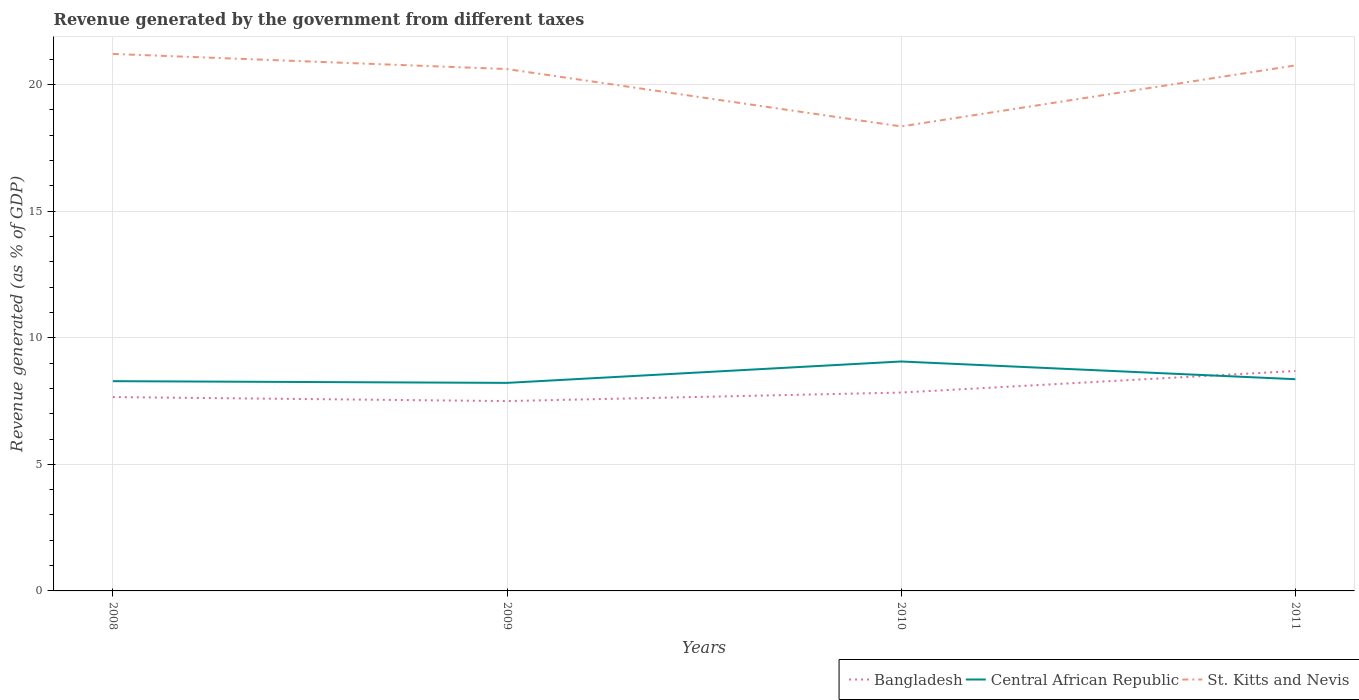Across all years, what is the maximum revenue generated by the government in St. Kitts and Nevis?
Offer a very short reply. 18.35. What is the total revenue generated by the government in Bangladesh in the graph?
Keep it short and to the point. -0.18. What is the difference between the highest and the second highest revenue generated by the government in Bangladesh?
Ensure brevity in your answer.  1.19. What is the difference between the highest and the lowest revenue generated by the government in St. Kitts and Nevis?
Offer a terse response. 3. Is the revenue generated by the government in St. Kitts and Nevis strictly greater than the revenue generated by the government in Central African Republic over the years?
Keep it short and to the point. No. How many years are there in the graph?
Your answer should be compact. 4. What is the difference between two consecutive major ticks on the Y-axis?
Your response must be concise. 5. Are the values on the major ticks of Y-axis written in scientific E-notation?
Provide a short and direct response. No. Does the graph contain any zero values?
Keep it short and to the point. No. Does the graph contain grids?
Give a very brief answer. Yes. Where does the legend appear in the graph?
Provide a short and direct response. Bottom right. What is the title of the graph?
Offer a terse response. Revenue generated by the government from different taxes. Does "Sao Tome and Principe" appear as one of the legend labels in the graph?
Give a very brief answer. No. What is the label or title of the X-axis?
Your response must be concise. Years. What is the label or title of the Y-axis?
Give a very brief answer. Revenue generated (as % of GDP). What is the Revenue generated (as % of GDP) of Bangladesh in 2008?
Your response must be concise. 7.66. What is the Revenue generated (as % of GDP) in Central African Republic in 2008?
Offer a terse response. 8.28. What is the Revenue generated (as % of GDP) in St. Kitts and Nevis in 2008?
Keep it short and to the point. 21.21. What is the Revenue generated (as % of GDP) in Bangladesh in 2009?
Your answer should be very brief. 7.5. What is the Revenue generated (as % of GDP) in Central African Republic in 2009?
Provide a succinct answer. 8.22. What is the Revenue generated (as % of GDP) of St. Kitts and Nevis in 2009?
Offer a very short reply. 20.61. What is the Revenue generated (as % of GDP) in Bangladesh in 2010?
Make the answer very short. 7.83. What is the Revenue generated (as % of GDP) in Central African Republic in 2010?
Your response must be concise. 9.06. What is the Revenue generated (as % of GDP) of St. Kitts and Nevis in 2010?
Offer a very short reply. 18.35. What is the Revenue generated (as % of GDP) of Bangladesh in 2011?
Your answer should be compact. 8.69. What is the Revenue generated (as % of GDP) of Central African Republic in 2011?
Give a very brief answer. 8.36. What is the Revenue generated (as % of GDP) of St. Kitts and Nevis in 2011?
Offer a terse response. 20.76. Across all years, what is the maximum Revenue generated (as % of GDP) of Bangladesh?
Offer a very short reply. 8.69. Across all years, what is the maximum Revenue generated (as % of GDP) in Central African Republic?
Make the answer very short. 9.06. Across all years, what is the maximum Revenue generated (as % of GDP) of St. Kitts and Nevis?
Your answer should be very brief. 21.21. Across all years, what is the minimum Revenue generated (as % of GDP) of Bangladesh?
Provide a short and direct response. 7.5. Across all years, what is the minimum Revenue generated (as % of GDP) in Central African Republic?
Make the answer very short. 8.22. Across all years, what is the minimum Revenue generated (as % of GDP) of St. Kitts and Nevis?
Make the answer very short. 18.35. What is the total Revenue generated (as % of GDP) in Bangladesh in the graph?
Offer a very short reply. 31.67. What is the total Revenue generated (as % of GDP) of Central African Republic in the graph?
Keep it short and to the point. 33.93. What is the total Revenue generated (as % of GDP) in St. Kitts and Nevis in the graph?
Keep it short and to the point. 80.92. What is the difference between the Revenue generated (as % of GDP) of Bangladesh in 2008 and that in 2009?
Your answer should be very brief. 0.16. What is the difference between the Revenue generated (as % of GDP) in Central African Republic in 2008 and that in 2009?
Offer a terse response. 0.07. What is the difference between the Revenue generated (as % of GDP) of St. Kitts and Nevis in 2008 and that in 2009?
Ensure brevity in your answer.  0.6. What is the difference between the Revenue generated (as % of GDP) in Bangladesh in 2008 and that in 2010?
Your answer should be very brief. -0.18. What is the difference between the Revenue generated (as % of GDP) of Central African Republic in 2008 and that in 2010?
Offer a terse response. -0.78. What is the difference between the Revenue generated (as % of GDP) of St. Kitts and Nevis in 2008 and that in 2010?
Give a very brief answer. 2.86. What is the difference between the Revenue generated (as % of GDP) of Bangladesh in 2008 and that in 2011?
Make the answer very short. -1.03. What is the difference between the Revenue generated (as % of GDP) of Central African Republic in 2008 and that in 2011?
Offer a very short reply. -0.08. What is the difference between the Revenue generated (as % of GDP) in St. Kitts and Nevis in 2008 and that in 2011?
Your answer should be compact. 0.45. What is the difference between the Revenue generated (as % of GDP) of Bangladesh in 2009 and that in 2010?
Your answer should be very brief. -0.34. What is the difference between the Revenue generated (as % of GDP) in Central African Republic in 2009 and that in 2010?
Your answer should be compact. -0.84. What is the difference between the Revenue generated (as % of GDP) of St. Kitts and Nevis in 2009 and that in 2010?
Keep it short and to the point. 2.27. What is the difference between the Revenue generated (as % of GDP) of Bangladesh in 2009 and that in 2011?
Provide a short and direct response. -1.19. What is the difference between the Revenue generated (as % of GDP) in Central African Republic in 2009 and that in 2011?
Provide a succinct answer. -0.14. What is the difference between the Revenue generated (as % of GDP) in St. Kitts and Nevis in 2009 and that in 2011?
Offer a terse response. -0.14. What is the difference between the Revenue generated (as % of GDP) of Bangladesh in 2010 and that in 2011?
Your answer should be compact. -0.85. What is the difference between the Revenue generated (as % of GDP) of Central African Republic in 2010 and that in 2011?
Offer a terse response. 0.7. What is the difference between the Revenue generated (as % of GDP) in St. Kitts and Nevis in 2010 and that in 2011?
Your response must be concise. -2.41. What is the difference between the Revenue generated (as % of GDP) of Bangladesh in 2008 and the Revenue generated (as % of GDP) of Central African Republic in 2009?
Keep it short and to the point. -0.56. What is the difference between the Revenue generated (as % of GDP) in Bangladesh in 2008 and the Revenue generated (as % of GDP) in St. Kitts and Nevis in 2009?
Keep it short and to the point. -12.96. What is the difference between the Revenue generated (as % of GDP) of Central African Republic in 2008 and the Revenue generated (as % of GDP) of St. Kitts and Nevis in 2009?
Make the answer very short. -12.33. What is the difference between the Revenue generated (as % of GDP) in Bangladesh in 2008 and the Revenue generated (as % of GDP) in Central African Republic in 2010?
Your answer should be very brief. -1.41. What is the difference between the Revenue generated (as % of GDP) in Bangladesh in 2008 and the Revenue generated (as % of GDP) in St. Kitts and Nevis in 2010?
Provide a short and direct response. -10.69. What is the difference between the Revenue generated (as % of GDP) of Central African Republic in 2008 and the Revenue generated (as % of GDP) of St. Kitts and Nevis in 2010?
Make the answer very short. -10.06. What is the difference between the Revenue generated (as % of GDP) in Bangladesh in 2008 and the Revenue generated (as % of GDP) in Central African Republic in 2011?
Your answer should be very brief. -0.71. What is the difference between the Revenue generated (as % of GDP) in Bangladesh in 2008 and the Revenue generated (as % of GDP) in St. Kitts and Nevis in 2011?
Keep it short and to the point. -13.1. What is the difference between the Revenue generated (as % of GDP) of Central African Republic in 2008 and the Revenue generated (as % of GDP) of St. Kitts and Nevis in 2011?
Your answer should be compact. -12.47. What is the difference between the Revenue generated (as % of GDP) of Bangladesh in 2009 and the Revenue generated (as % of GDP) of Central African Republic in 2010?
Ensure brevity in your answer.  -1.56. What is the difference between the Revenue generated (as % of GDP) in Bangladesh in 2009 and the Revenue generated (as % of GDP) in St. Kitts and Nevis in 2010?
Provide a short and direct response. -10.85. What is the difference between the Revenue generated (as % of GDP) in Central African Republic in 2009 and the Revenue generated (as % of GDP) in St. Kitts and Nevis in 2010?
Keep it short and to the point. -10.13. What is the difference between the Revenue generated (as % of GDP) of Bangladesh in 2009 and the Revenue generated (as % of GDP) of Central African Republic in 2011?
Offer a very short reply. -0.86. What is the difference between the Revenue generated (as % of GDP) in Bangladesh in 2009 and the Revenue generated (as % of GDP) in St. Kitts and Nevis in 2011?
Keep it short and to the point. -13.26. What is the difference between the Revenue generated (as % of GDP) of Central African Republic in 2009 and the Revenue generated (as % of GDP) of St. Kitts and Nevis in 2011?
Your answer should be compact. -12.54. What is the difference between the Revenue generated (as % of GDP) of Bangladesh in 2010 and the Revenue generated (as % of GDP) of Central African Republic in 2011?
Offer a terse response. -0.53. What is the difference between the Revenue generated (as % of GDP) in Bangladesh in 2010 and the Revenue generated (as % of GDP) in St. Kitts and Nevis in 2011?
Offer a terse response. -12.92. What is the difference between the Revenue generated (as % of GDP) of Central African Republic in 2010 and the Revenue generated (as % of GDP) of St. Kitts and Nevis in 2011?
Keep it short and to the point. -11.69. What is the average Revenue generated (as % of GDP) of Bangladesh per year?
Your answer should be very brief. 7.92. What is the average Revenue generated (as % of GDP) of Central African Republic per year?
Keep it short and to the point. 8.48. What is the average Revenue generated (as % of GDP) in St. Kitts and Nevis per year?
Your answer should be very brief. 20.23. In the year 2008, what is the difference between the Revenue generated (as % of GDP) of Bangladesh and Revenue generated (as % of GDP) of Central African Republic?
Your response must be concise. -0.63. In the year 2008, what is the difference between the Revenue generated (as % of GDP) in Bangladesh and Revenue generated (as % of GDP) in St. Kitts and Nevis?
Give a very brief answer. -13.55. In the year 2008, what is the difference between the Revenue generated (as % of GDP) in Central African Republic and Revenue generated (as % of GDP) in St. Kitts and Nevis?
Provide a succinct answer. -12.92. In the year 2009, what is the difference between the Revenue generated (as % of GDP) in Bangladesh and Revenue generated (as % of GDP) in Central African Republic?
Offer a very short reply. -0.72. In the year 2009, what is the difference between the Revenue generated (as % of GDP) in Bangladesh and Revenue generated (as % of GDP) in St. Kitts and Nevis?
Offer a very short reply. -13.11. In the year 2009, what is the difference between the Revenue generated (as % of GDP) in Central African Republic and Revenue generated (as % of GDP) in St. Kitts and Nevis?
Provide a short and direct response. -12.39. In the year 2010, what is the difference between the Revenue generated (as % of GDP) in Bangladesh and Revenue generated (as % of GDP) in Central African Republic?
Make the answer very short. -1.23. In the year 2010, what is the difference between the Revenue generated (as % of GDP) of Bangladesh and Revenue generated (as % of GDP) of St. Kitts and Nevis?
Provide a short and direct response. -10.51. In the year 2010, what is the difference between the Revenue generated (as % of GDP) of Central African Republic and Revenue generated (as % of GDP) of St. Kitts and Nevis?
Ensure brevity in your answer.  -9.28. In the year 2011, what is the difference between the Revenue generated (as % of GDP) in Bangladesh and Revenue generated (as % of GDP) in Central African Republic?
Ensure brevity in your answer.  0.32. In the year 2011, what is the difference between the Revenue generated (as % of GDP) in Bangladesh and Revenue generated (as % of GDP) in St. Kitts and Nevis?
Your answer should be very brief. -12.07. In the year 2011, what is the difference between the Revenue generated (as % of GDP) in Central African Republic and Revenue generated (as % of GDP) in St. Kitts and Nevis?
Offer a terse response. -12.39. What is the ratio of the Revenue generated (as % of GDP) of Bangladesh in 2008 to that in 2009?
Give a very brief answer. 1.02. What is the ratio of the Revenue generated (as % of GDP) in Central African Republic in 2008 to that in 2009?
Give a very brief answer. 1.01. What is the ratio of the Revenue generated (as % of GDP) of St. Kitts and Nevis in 2008 to that in 2009?
Your response must be concise. 1.03. What is the ratio of the Revenue generated (as % of GDP) in Bangladesh in 2008 to that in 2010?
Your answer should be very brief. 0.98. What is the ratio of the Revenue generated (as % of GDP) of Central African Republic in 2008 to that in 2010?
Offer a terse response. 0.91. What is the ratio of the Revenue generated (as % of GDP) in St. Kitts and Nevis in 2008 to that in 2010?
Offer a terse response. 1.16. What is the ratio of the Revenue generated (as % of GDP) of Bangladesh in 2008 to that in 2011?
Your answer should be very brief. 0.88. What is the ratio of the Revenue generated (as % of GDP) of Central African Republic in 2008 to that in 2011?
Give a very brief answer. 0.99. What is the ratio of the Revenue generated (as % of GDP) in St. Kitts and Nevis in 2008 to that in 2011?
Provide a short and direct response. 1.02. What is the ratio of the Revenue generated (as % of GDP) in Central African Republic in 2009 to that in 2010?
Offer a terse response. 0.91. What is the ratio of the Revenue generated (as % of GDP) of St. Kitts and Nevis in 2009 to that in 2010?
Provide a short and direct response. 1.12. What is the ratio of the Revenue generated (as % of GDP) in Bangladesh in 2009 to that in 2011?
Make the answer very short. 0.86. What is the ratio of the Revenue generated (as % of GDP) in Central African Republic in 2009 to that in 2011?
Offer a very short reply. 0.98. What is the ratio of the Revenue generated (as % of GDP) of St. Kitts and Nevis in 2009 to that in 2011?
Keep it short and to the point. 0.99. What is the ratio of the Revenue generated (as % of GDP) in Bangladesh in 2010 to that in 2011?
Make the answer very short. 0.9. What is the ratio of the Revenue generated (as % of GDP) in Central African Republic in 2010 to that in 2011?
Keep it short and to the point. 1.08. What is the ratio of the Revenue generated (as % of GDP) of St. Kitts and Nevis in 2010 to that in 2011?
Provide a short and direct response. 0.88. What is the difference between the highest and the second highest Revenue generated (as % of GDP) in Bangladesh?
Make the answer very short. 0.85. What is the difference between the highest and the second highest Revenue generated (as % of GDP) of Central African Republic?
Your response must be concise. 0.7. What is the difference between the highest and the second highest Revenue generated (as % of GDP) in St. Kitts and Nevis?
Your answer should be very brief. 0.45. What is the difference between the highest and the lowest Revenue generated (as % of GDP) of Bangladesh?
Provide a succinct answer. 1.19. What is the difference between the highest and the lowest Revenue generated (as % of GDP) of Central African Republic?
Offer a very short reply. 0.84. What is the difference between the highest and the lowest Revenue generated (as % of GDP) of St. Kitts and Nevis?
Keep it short and to the point. 2.86. 